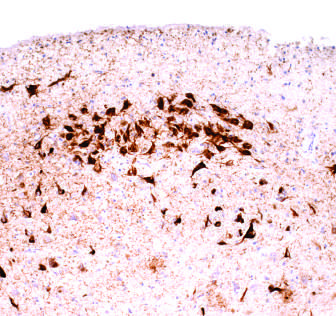what are neurons containing tangles stained with?
Answer the question using a single word or phrase. An antibody specific for tau 